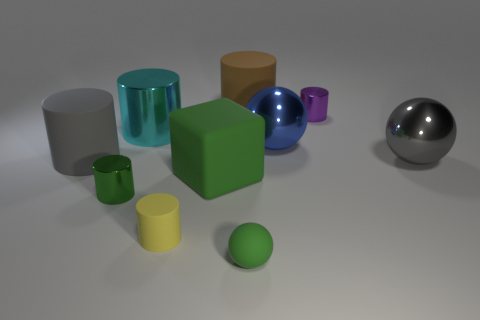What number of objects are large green shiny things or big rubber cylinders in front of the large metallic cylinder?
Give a very brief answer. 1. Is there a small yellow object that has the same shape as the big blue metallic thing?
Offer a terse response. No. Are there the same number of big rubber cylinders that are on the right side of the yellow cylinder and big gray spheres in front of the green cylinder?
Provide a short and direct response. No. Is there anything else that is the same size as the gray metal object?
Ensure brevity in your answer.  Yes. How many green objects are small matte balls or tiny cylinders?
Offer a very short reply. 2. How many brown rubber cylinders have the same size as the blue sphere?
Make the answer very short. 1. There is a metallic object that is both right of the rubber sphere and behind the big blue sphere; what color is it?
Make the answer very short. Purple. Is the number of cyan metallic things that are on the right side of the gray cylinder greater than the number of tiny metallic cylinders?
Provide a succinct answer. No. Are any large blue things visible?
Make the answer very short. Yes. Does the small ball have the same color as the small matte cylinder?
Offer a very short reply. No. 